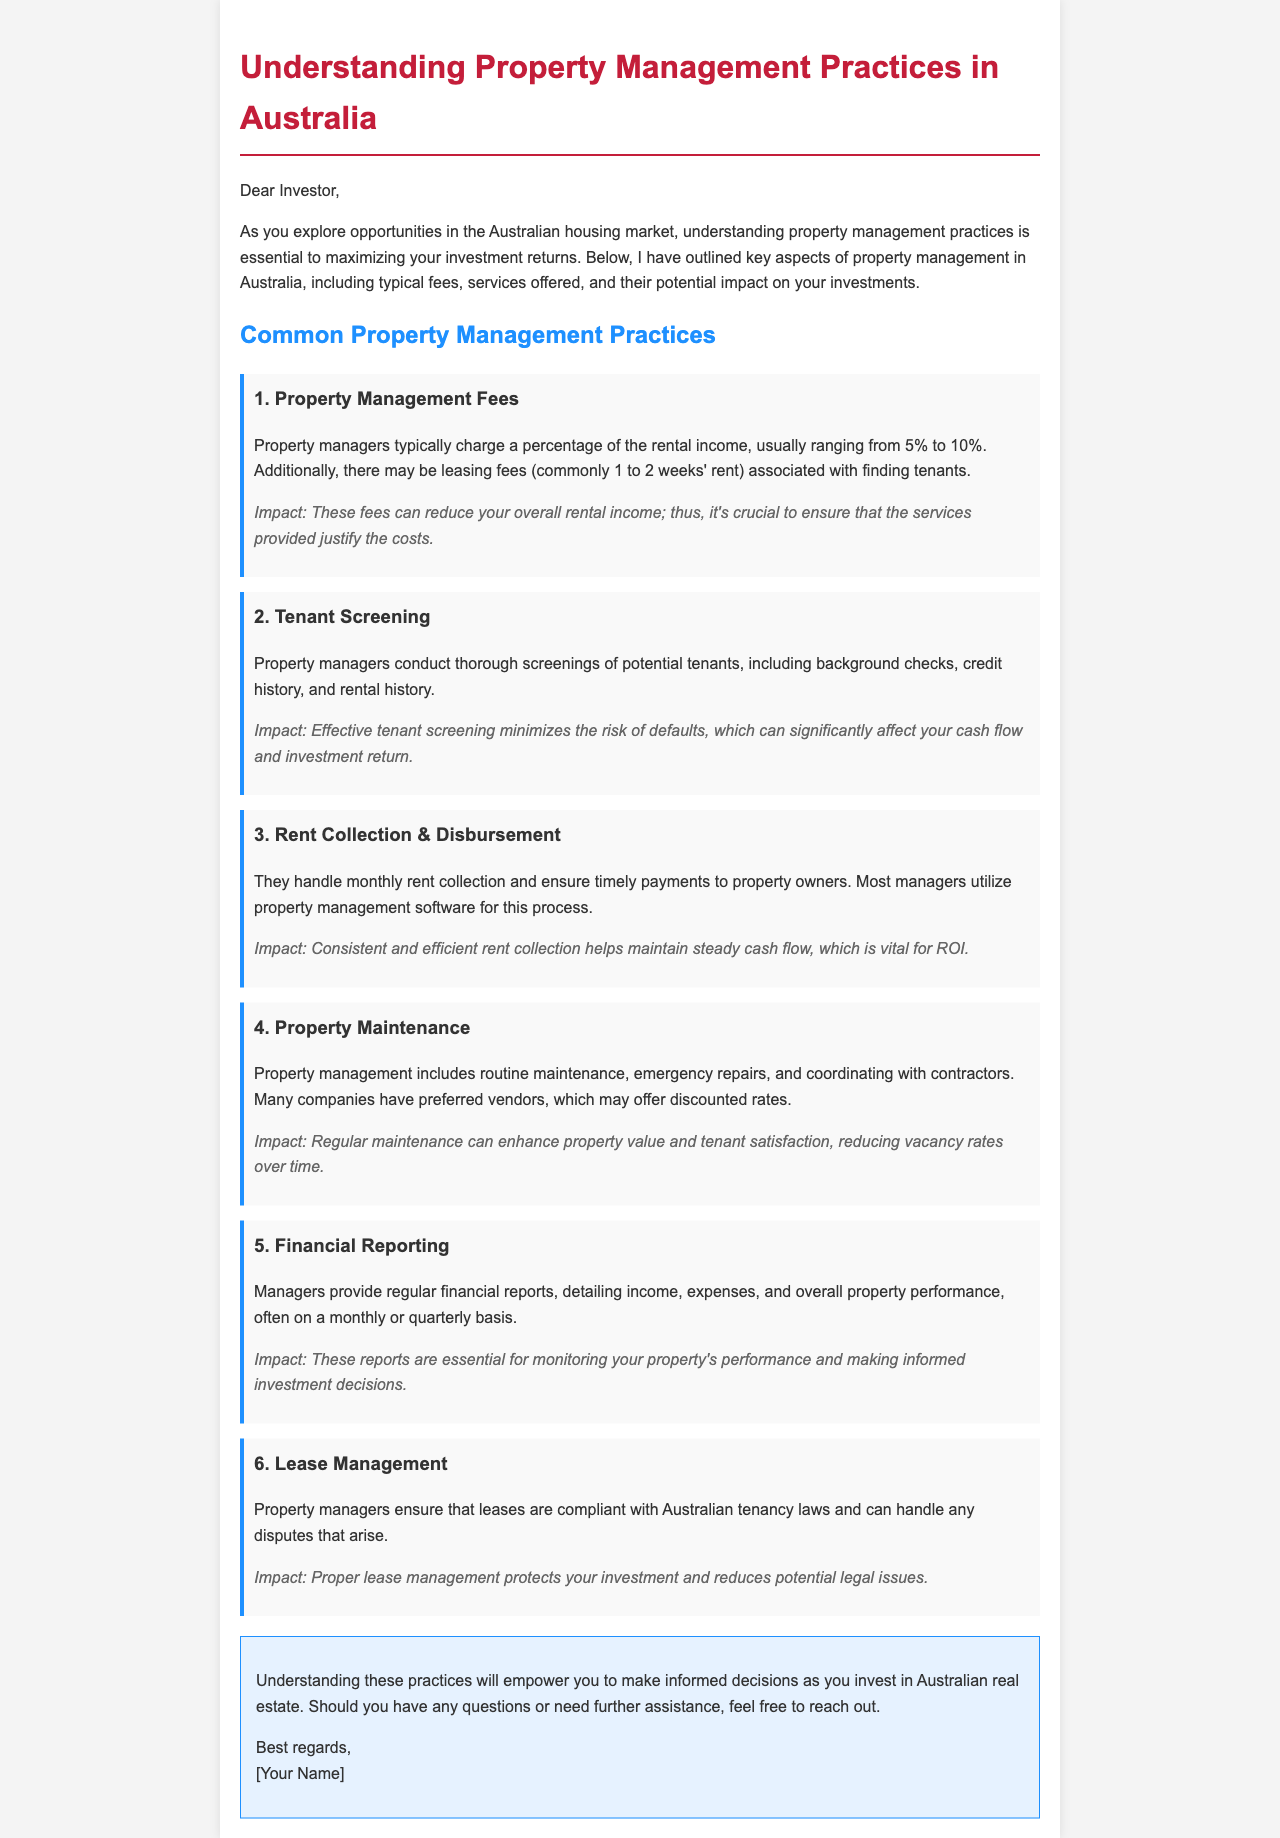What is the typical percentage range for property management fees? The typical property management fees range from 5% to 10% of the rental income.
Answer: 5% to 10% What is the common leasing fee associated with finding tenants? The leasing fee is commonly 1 to 2 weeks' rent for finding tenants.
Answer: 1 to 2 weeks' rent What service minimizes the risk of default by tenants? Effective tenant screening minimizes the risk of defaults.
Answer: Tenant screening What is crucial for maintaining steady cash flow? Consistent and efficient rent collection is vital for maintaining steady cash flow.
Answer: Rent collection What should property managers ensure about leases? Property managers should ensure leases are compliant with Australian tenancy laws.
Answer: Compliance with laws What aspect of management can enhance property value? Regular maintenance can enhance property value and tenant satisfaction.
Answer: Regular maintenance How often do managers provide financial reports? Managers provide financial reports often on a monthly or quarterly basis.
Answer: Monthly or quarterly What is the main purpose of tenant screening? The main purpose of tenant screening is to conduct thorough screenings of potential tenants.
Answer: Conduct thorough screenings Who can handle disputes that arise from lease management? Property managers can handle any disputes that arise from lease management.
Answer: Property managers 